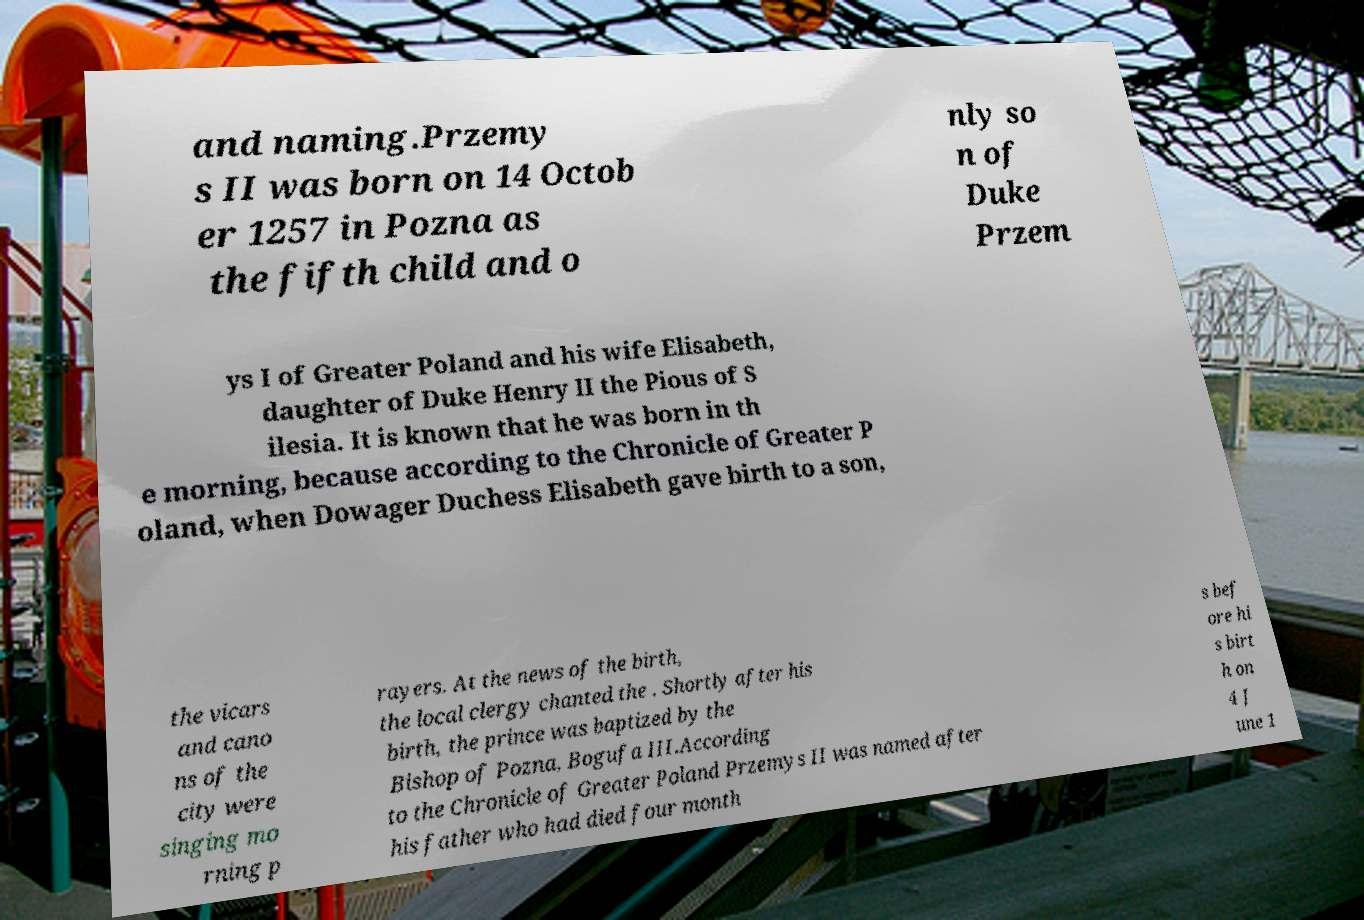I need the written content from this picture converted into text. Can you do that? and naming.Przemy s II was born on 14 Octob er 1257 in Pozna as the fifth child and o nly so n of Duke Przem ys I of Greater Poland and his wife Elisabeth, daughter of Duke Henry II the Pious of S ilesia. It is known that he was born in th e morning, because according to the Chronicle of Greater P oland, when Dowager Duchess Elisabeth gave birth to a son, the vicars and cano ns of the city were singing mo rning p rayers. At the news of the birth, the local clergy chanted the . Shortly after his birth, the prince was baptized by the Bishop of Pozna, Bogufa III.According to the Chronicle of Greater Poland Przemys II was named after his father who had died four month s bef ore hi s birt h on 4 J une 1 